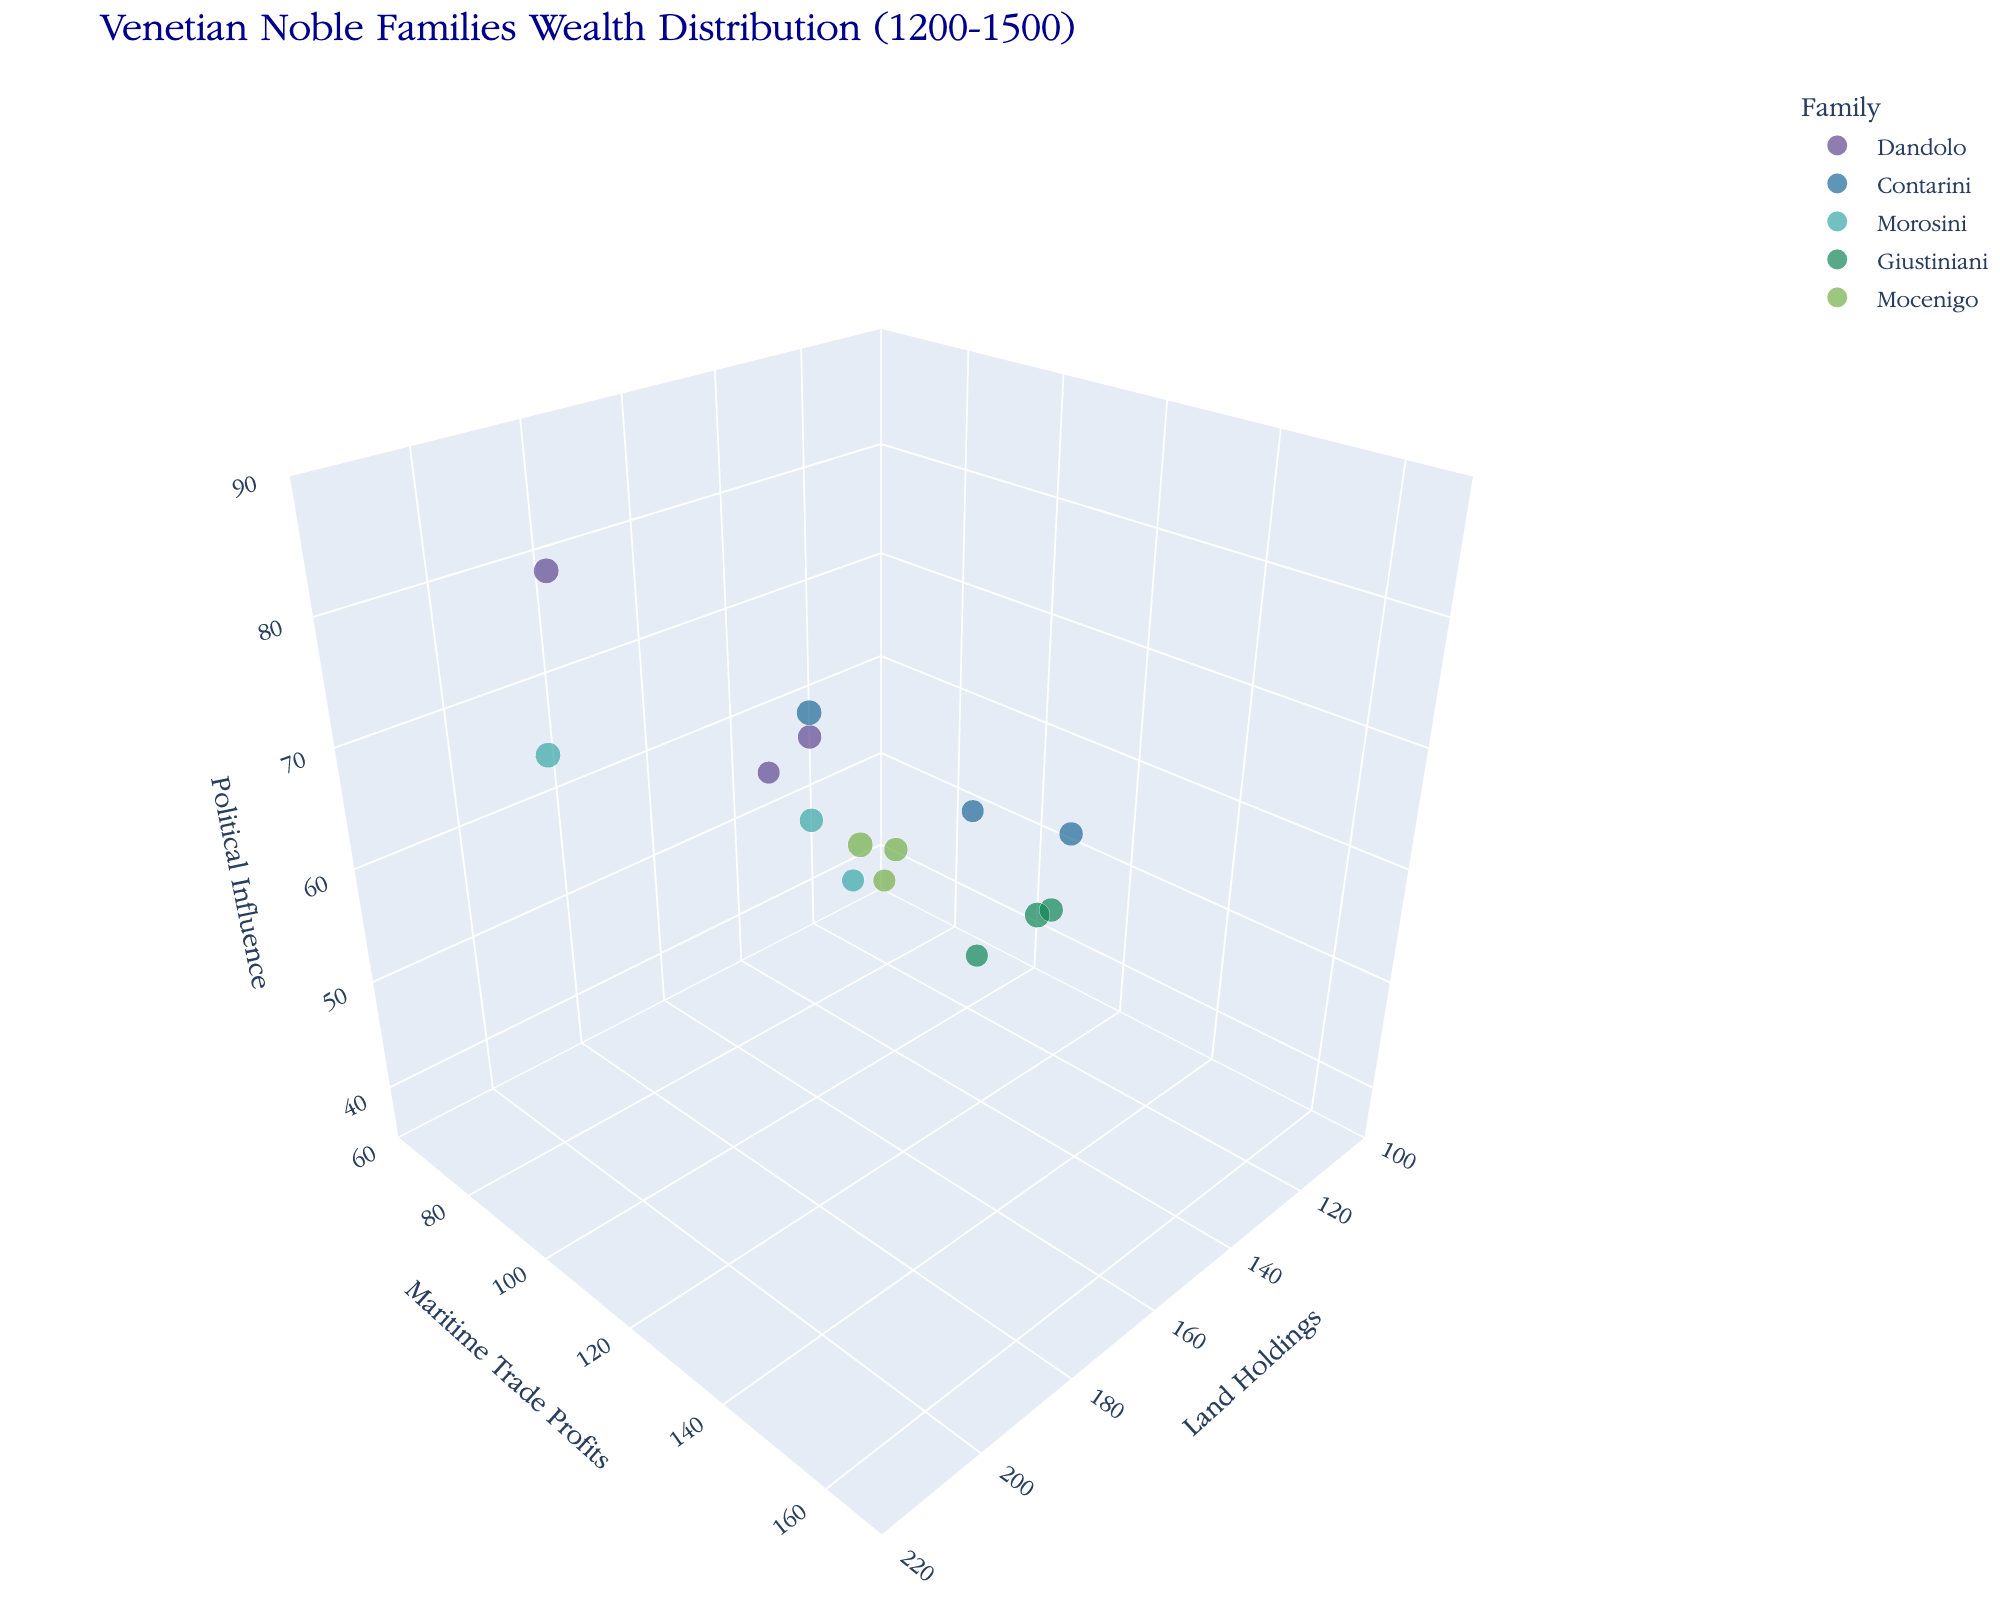How many families are represented in the plot? There are five different families listed in the legend: Dandolo, Contarini, Morosini, Giustiniani, and Mocenigo.
Answer: 5 Which family had the highest land holdings in the year 1500? By examining the bubbles for each family in the year 1500, we see that Morosini's bubble is located at the highest position along the 'Land Holdings' axis.
Answer: Morosini What was the difference in maritime trade profits for the Contarini family between the year 1200 and 1500? The maritime trade profits of the Contarini family were 100 in 1200 and 130 in 1500. The difference is 130 - 100 = 30.
Answer: 30 Which family had consistently increasing political influence from 1200 to 1500? By observing the positions of each family's bubbles along the 'Political Influence' axis from 1200 to 1500, the Dandolo family shows a consistent increase: 60 in 1200, 75 in 1350, and 85 in 1500.
Answer: Dandolo What is the average land holdings for the Giustiniani family across all shown years? Sum the land holdings for Giustiniani: 130 (1200) + 150 (1350) + 180 (1500). The total is 460, and there are three data points. Thus, the average is 460 / 3 = ~153.33.
Answer: ~153.33 Which family in the year 1350 had the largest maritime trade profits? The figure shows that the Contarini family has the largest bubble size in the year 1350 along the 'Maritime Trade Profits' axis at 150 profits.
Answer: Contarini How do the political influences of the Dandolo family in 1200 and Giustiniani family in 1350 compare? The political influence of the Dandolo family in 1200 is 60, and for the Giustiniani family in 1350, it is 60 as well, indicating they are equal.
Answer: Equal Which family exhibited the most significant increase in land holdings from 1200 to 1500? Calculate the increase for each family: 
Dandolo: 200 - 150 = 50,
Contarini: 190 - 120 = 70,
Morosini: 210 - 140 = 70,
Giustiniani: 180 - 130 = 50,
Mocenigo: 170 - 110 = 60. 
Both Contarini and Morosini had the largest increases of 70.
Answer: Contarini and Morosini What trend is observed for the maritime trade profits of the Mocenigo family from 1200 to 1500? Analyzing the bubbles for Mocenigo, the maritime trade profits increase from 70 in 1200, to 100 in 1350, and 120 in 1500, indicating a rising trend.
Answer: Rising trend Are the political influences of the Morosini and Mocenigo families in 1500 different? If so, by how much? The political influence for Morosini in 1500 is 75, and for Mocenigo, it is 65. The difference is 75 - 65 = 10.
Answer: 10 